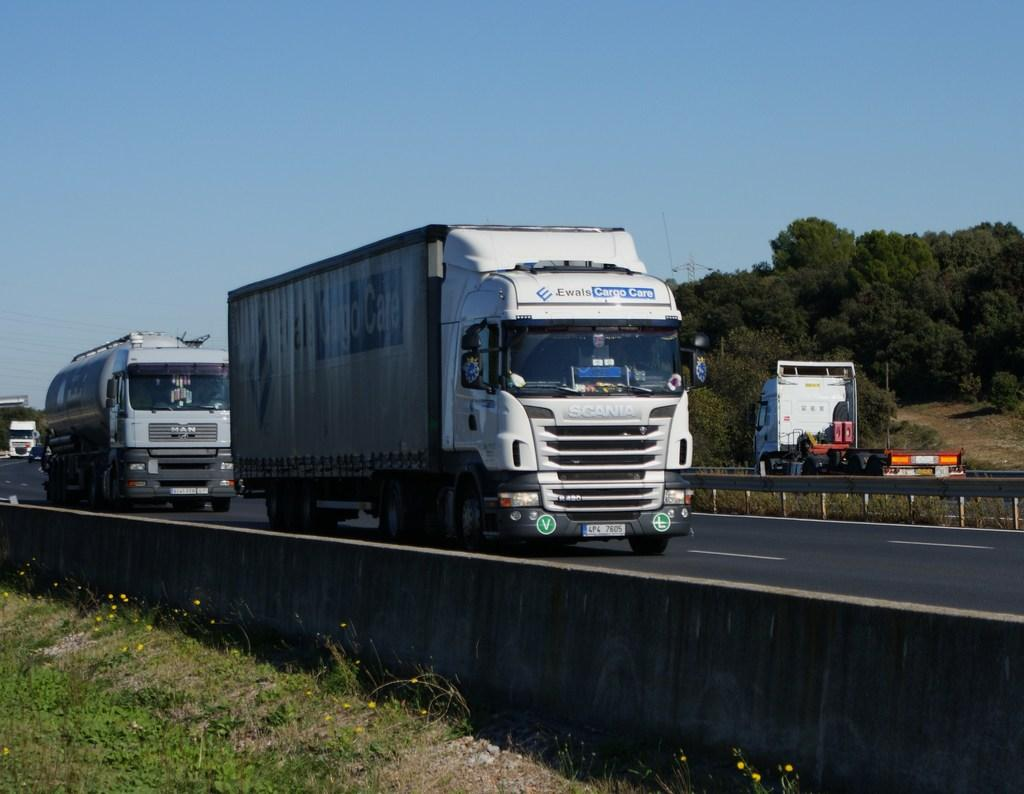What type of terrain can be seen in the image? There is grass and sand visible in the image. What type of structure is present in the image? There is a wall in the image. What type of pathway is visible in the image? There is a road visible in the image. What type of vehicles can be seen in the image? There are vehicles in the image. Can you describe the background of the image? In the background of the image, there is a truck, trees, and the sky visible. What degree does the basketball player need to achieve in order to make the shot in the image? There is no basketball player or shot present in the image, so it is not possible to answer that question. 